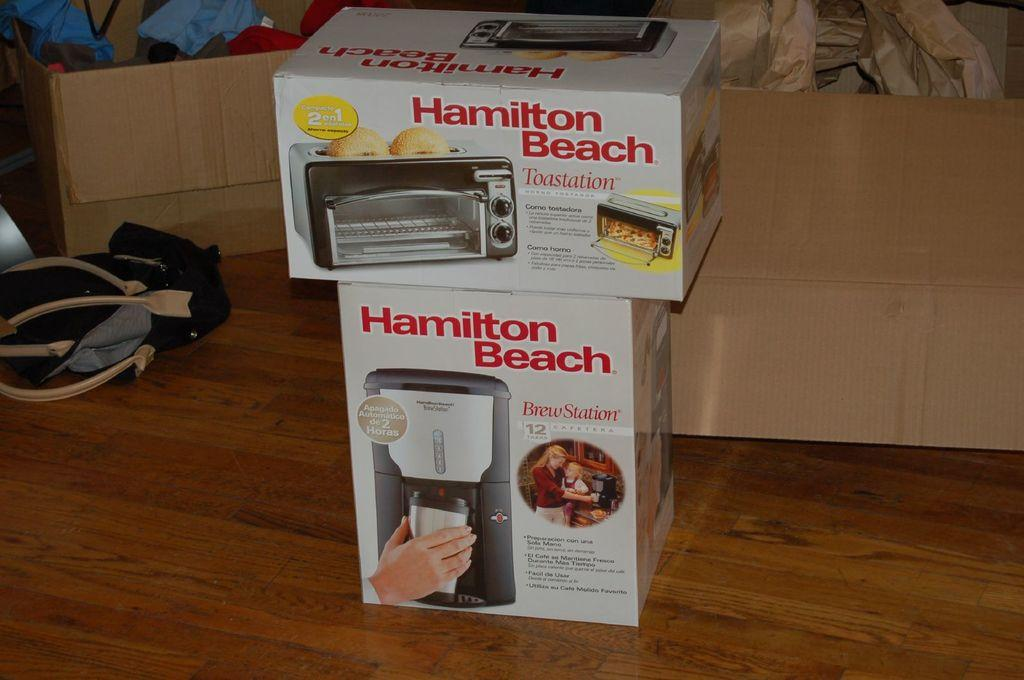Provide a one-sentence caption for the provided image. A Hamilton Beach toaster oven box sits on top of a Hamilton Beach coffee maker box. 